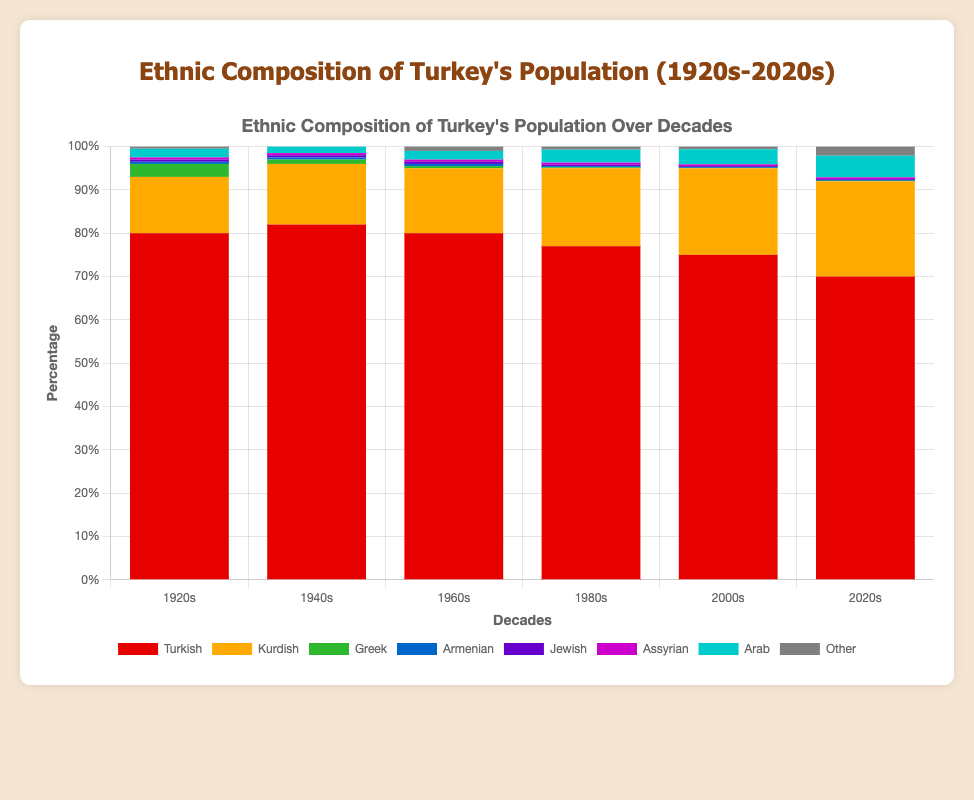What is the percentage difference between the Turkish population in the 1920s and the 2020s? The Turkish population is 80% in the 1920s and 70% in the 2020s. The difference is 80% - 70% = 10%.
Answer: 10% Which decade saw the highest percentage of the Kurdish population? Referring to the data, the Kurdish population increases steadily across decades, with the highest percentage being 22% in the 2020s.
Answer: 2020s During which decade did the Greek population see the most significant decline? The Greek population decreases from 3% in the 1920s to 1% in the 1940s, which is the most significant drop of 2%.
Answer: 1940s What's the total percentage of Assyrian and Armenian populations in the 1960s? The Assyrian population is 0.5%, and the Armenian population is 0.5%, summing up to 0.5% + 0.5% = 1%.
Answer: 1% Which ethnic group has consistently remained a small percentage (under 1%) of the total population across all decades? The data shows that Assyrian and Armenian populations both remain under 1% across all decades.
Answer: Assyrian and Armenian Compare the Arab population between the 1940s and the 2020s. Has it increased or decreased, and by what percentage? The Arab population increases from 1.5% in the 1940s to 5% in the 2020s, an increase of 5% - 1.5% = 3.5%.
Answer: Increased by 3.5% What is the percentage change in the "Other" category from the 1920s to the 2020s? The "Other" category is 0.5% in the 1920s and 2.1% in the 2020s. The change is 2.1% - 0.5% = 1.6%.
Answer: 1.6% Which decade had the highest percentage of the Turkish population? The highest percentage of the Turkish population is 82%, which occurred in the 1940s.
Answer: 1940s 